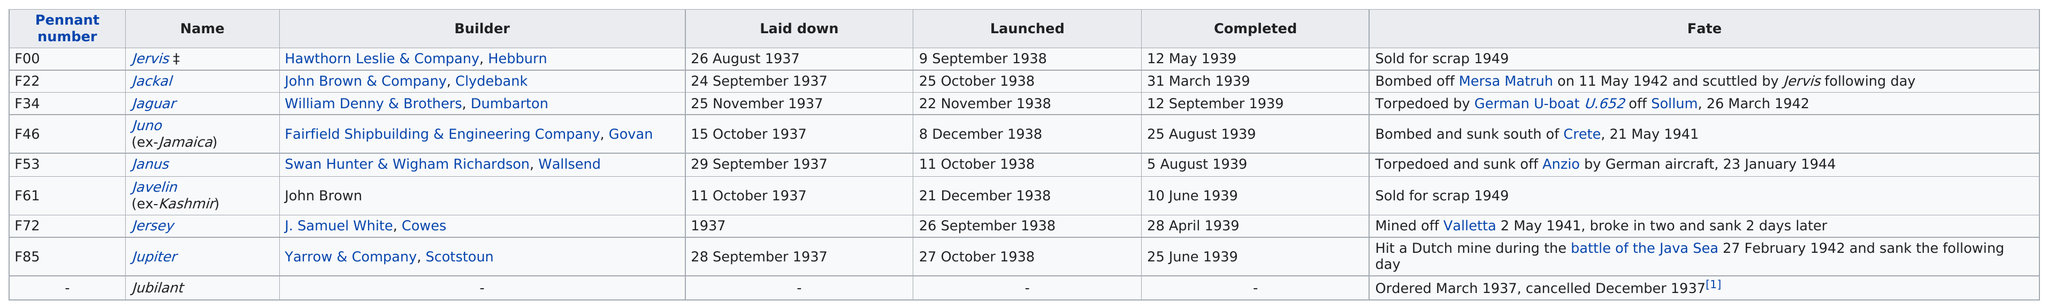Mention a couple of crucial points in this snapshot. Of the 4 ships, 4 were sunk. The Jaguar lasted longer than the Jersey. After 1945, several destroyers, including the Javelin, were sold for scrap. In August 1939, a total of two destroyers were completed. The fate of the F00 Jervis was the same as that of the Javelin (formerly Kashmir), 